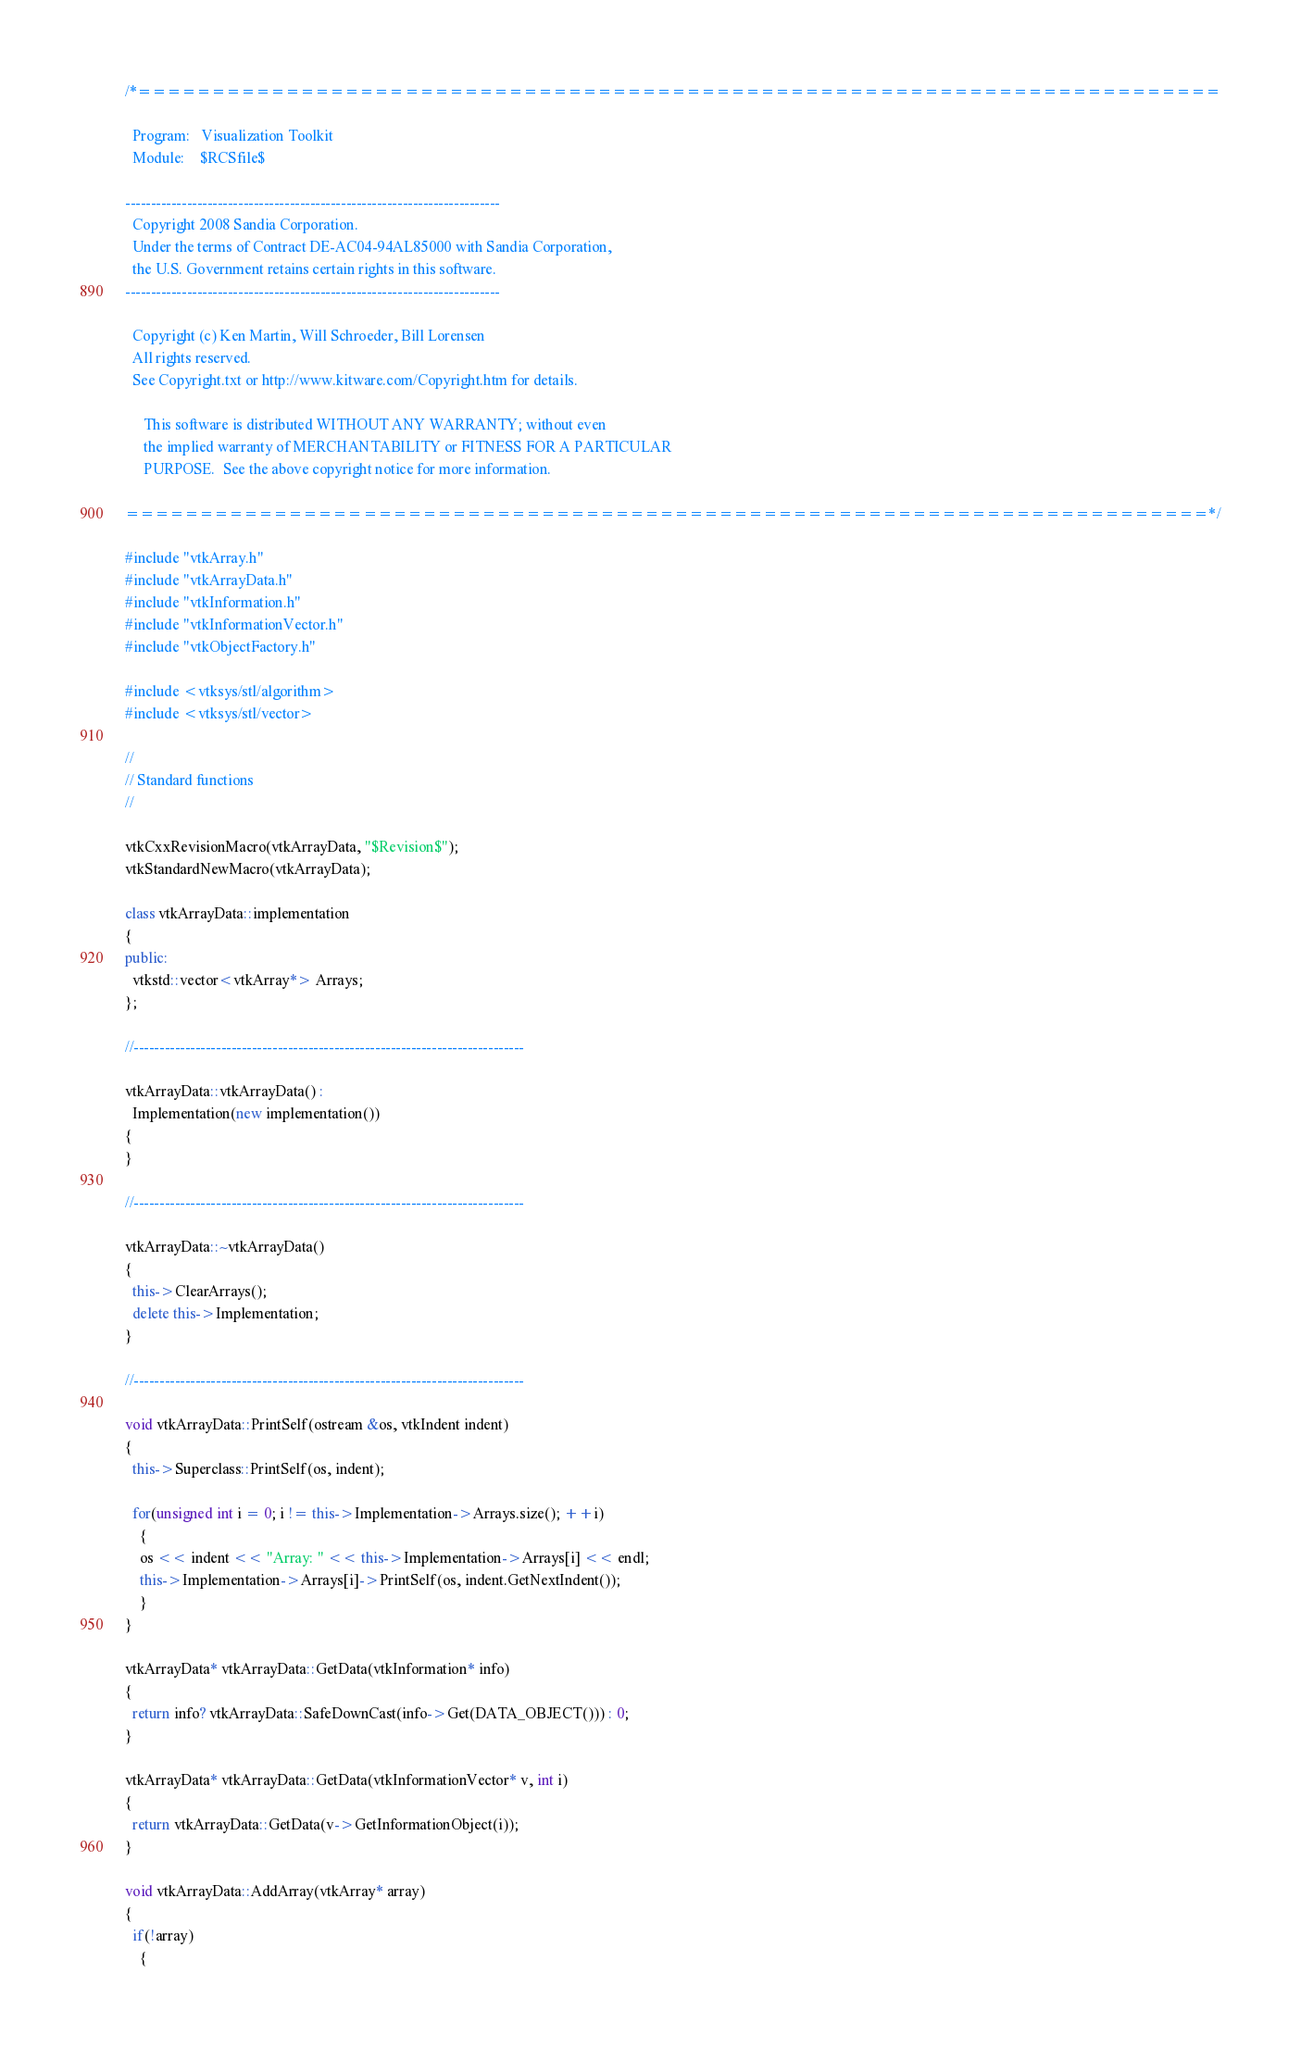<code> <loc_0><loc_0><loc_500><loc_500><_C++_>/*=========================================================================

  Program:   Visualization Toolkit
  Module:    $RCSfile$
  
-------------------------------------------------------------------------
  Copyright 2008 Sandia Corporation.
  Under the terms of Contract DE-AC04-94AL85000 with Sandia Corporation,
  the U.S. Government retains certain rights in this software.
-------------------------------------------------------------------------

  Copyright (c) Ken Martin, Will Schroeder, Bill Lorensen
  All rights reserved.
  See Copyright.txt or http://www.kitware.com/Copyright.htm for details.

     This software is distributed WITHOUT ANY WARRANTY; without even
     the implied warranty of MERCHANTABILITY or FITNESS FOR A PARTICULAR
     PURPOSE.  See the above copyright notice for more information.

=========================================================================*/

#include "vtkArray.h"
#include "vtkArrayData.h"
#include "vtkInformation.h"
#include "vtkInformationVector.h"
#include "vtkObjectFactory.h"

#include <vtksys/stl/algorithm>
#include <vtksys/stl/vector>

//
// Standard functions
//

vtkCxxRevisionMacro(vtkArrayData, "$Revision$");
vtkStandardNewMacro(vtkArrayData);

class vtkArrayData::implementation
{
public:
  vtkstd::vector<vtkArray*> Arrays;
};

//----------------------------------------------------------------------------

vtkArrayData::vtkArrayData() :
  Implementation(new implementation())
{
}

//----------------------------------------------------------------------------

vtkArrayData::~vtkArrayData()
{
  this->ClearArrays();
  delete this->Implementation;
}

//----------------------------------------------------------------------------

void vtkArrayData::PrintSelf(ostream &os, vtkIndent indent)
{
  this->Superclass::PrintSelf(os, indent);

  for(unsigned int i = 0; i != this->Implementation->Arrays.size(); ++i)
    {
    os << indent << "Array: " << this->Implementation->Arrays[i] << endl;
    this->Implementation->Arrays[i]->PrintSelf(os, indent.GetNextIndent());
    }
}

vtkArrayData* vtkArrayData::GetData(vtkInformation* info)
{
  return info? vtkArrayData::SafeDownCast(info->Get(DATA_OBJECT())) : 0;
}

vtkArrayData* vtkArrayData::GetData(vtkInformationVector* v, int i)
{
  return vtkArrayData::GetData(v->GetInformationObject(i));
}

void vtkArrayData::AddArray(vtkArray* array)
{
  if(!array)
    {</code> 